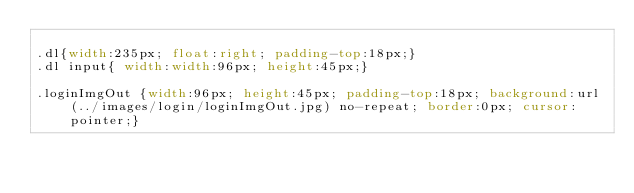Convert code to text. <code><loc_0><loc_0><loc_500><loc_500><_CSS_>
.dl{width:235px; float:right; padding-top:18px;}
.dl input{ width:width:96px; height:45px;}

.loginImgOut {width:96px; height:45px; padding-top:18px; background:url(../images/login/loginImgOut.jpg) no-repeat; border:0px; cursor:pointer;}</code> 